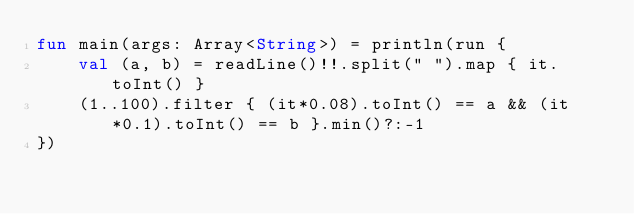Convert code to text. <code><loc_0><loc_0><loc_500><loc_500><_Kotlin_>fun main(args: Array<String>) = println(run {
    val (a, b) = readLine()!!.split(" ").map { it.toInt() }
    (1..100).filter { (it*0.08).toInt() == a && (it*0.1).toInt() == b }.min()?:-1
})</code> 